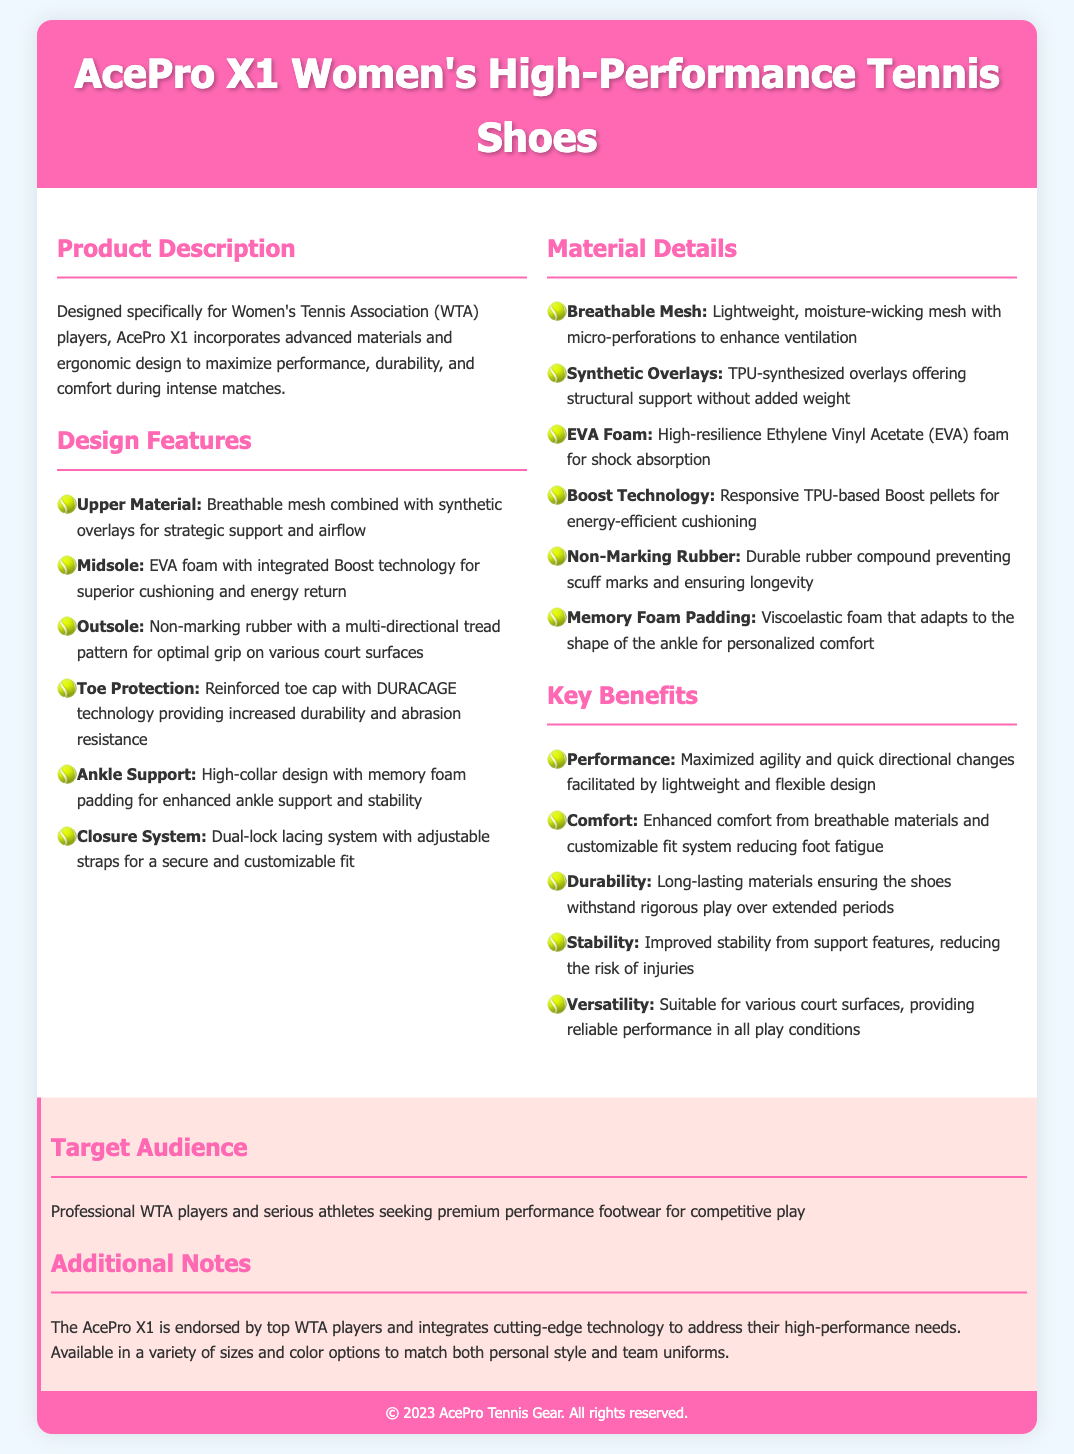What is the name of the shoe? The shoe is named in the header section of the document, which mentions "AcePro X1 Women's High-Performance Tennis Shoes."
Answer: AcePro X1 Women's High-Performance Tennis Shoes Who is the target audience for these shoes? The target audience section states that the shoes are for "Professional WTA players and serious athletes seeking premium performance footwear for competitive play."
Answer: Professional WTA players What technology does the midsole feature? The specifications detail that the midsole incorporates "Boost technology for superior cushioning and energy return."
Answer: Boost technology What is the upper material made of? The document specifies that the upper material consists of "Breathable mesh combined with synthetic overlays for strategic support and airflow."
Answer: Breathable mesh combined with synthetic overlays How many design features are listed? The "Design Features" section includes a total of six distinct features mentioned in bullet points.
Answer: Six What type of rubber is used for the outsole? The document describes the outsole as "Non-marking rubber with a multi-directional tread pattern for optimal grip."
Answer: Non-marking rubber What is the purpose of the dual-lock lacing system? The "Closure System" section notes that the dual-lock lacing system provides "a secure and customizable fit."
Answer: Secure and customizable fit What added benefit is provided by the memory foam padding? The materials section mentions that memory foam padding "adapts to the shape of the ankle for personalized comfort."
Answer: Personalized comfort 